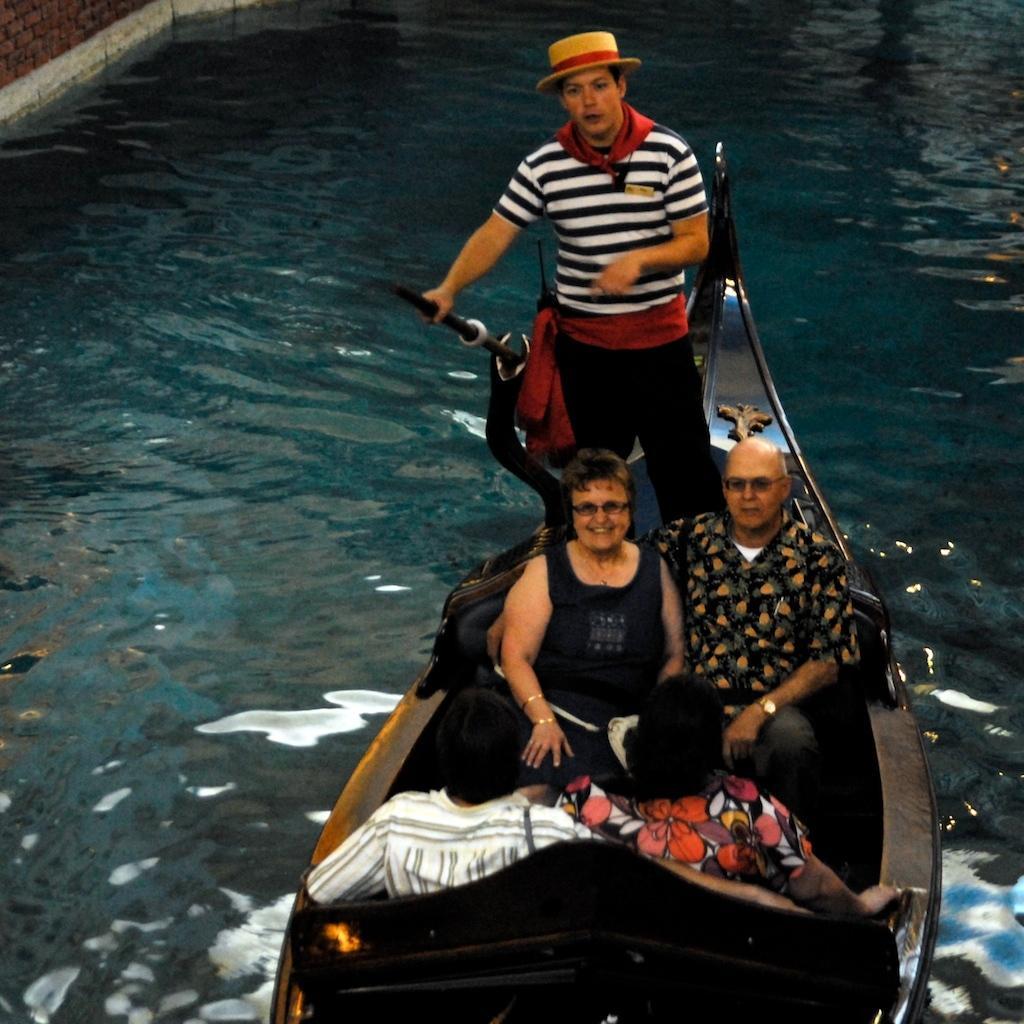Describe this image in one or two sentences. There are four persons in different color dresses sitting on the seats of a boat. On which, there is a person standing and driving it on the water. In the background, there is a brick wall. 